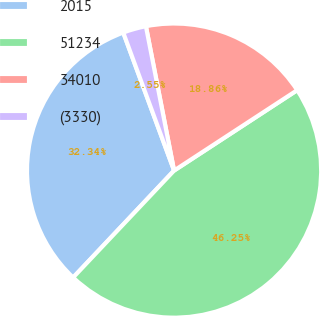Convert chart. <chart><loc_0><loc_0><loc_500><loc_500><pie_chart><fcel>2015<fcel>51234<fcel>34010<fcel>(3330)<nl><fcel>32.34%<fcel>46.25%<fcel>18.86%<fcel>2.55%<nl></chart> 